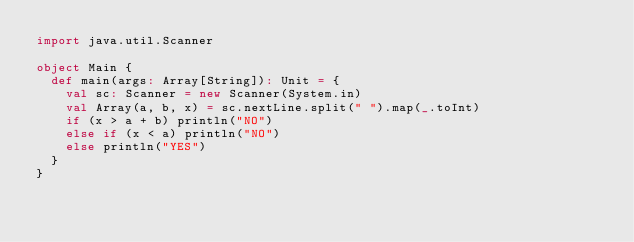Convert code to text. <code><loc_0><loc_0><loc_500><loc_500><_Scala_>import java.util.Scanner

object Main {
  def main(args: Array[String]): Unit = {
    val sc: Scanner = new Scanner(System.in)
    val Array(a, b, x) = sc.nextLine.split(" ").map(_.toInt)
    if (x > a + b) println("NO")
    else if (x < a) println("NO")
    else println("YES")
  }
}
</code> 